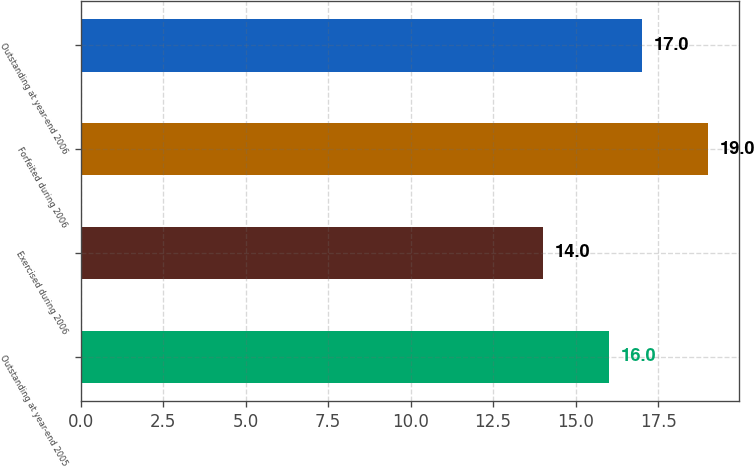Convert chart to OTSL. <chart><loc_0><loc_0><loc_500><loc_500><bar_chart><fcel>Outstanding at year-end 2005<fcel>Exercised during 2006<fcel>Forfeited during 2006<fcel>Outstanding at year-end 2006<nl><fcel>16<fcel>14<fcel>19<fcel>17<nl></chart> 